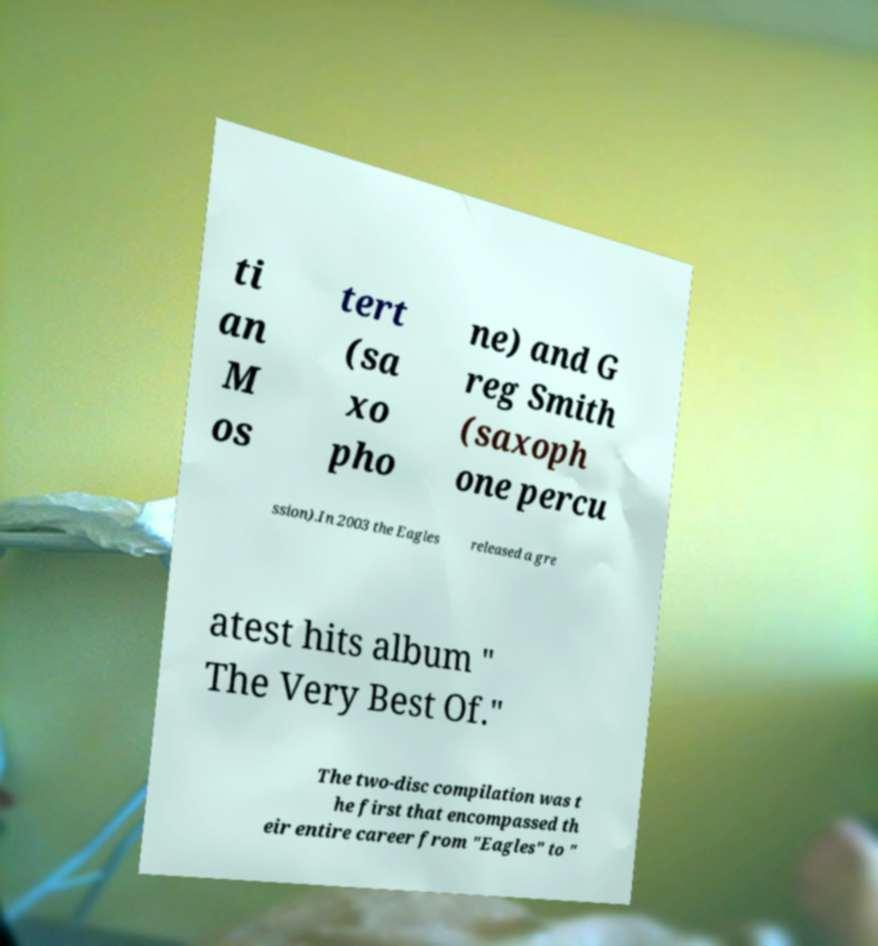Can you accurately transcribe the text from the provided image for me? ti an M os tert (sa xo pho ne) and G reg Smith (saxoph one percu ssion).In 2003 the Eagles released a gre atest hits album " The Very Best Of." The two-disc compilation was t he first that encompassed th eir entire career from "Eagles" to " 